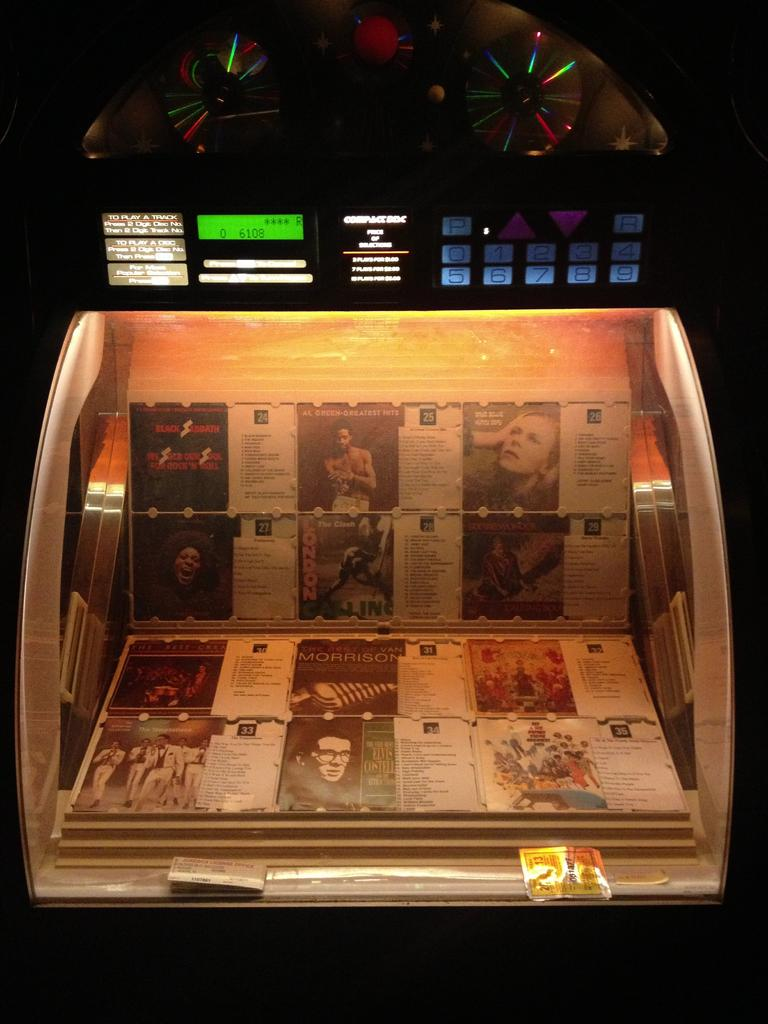What is placed on top of the box in the image? There is an amplifier or electronic machine at the top of the image. What is located on the box in the image? Papers are on the box in the image. How would you describe the lighting at the bottom of the image? The bottom of the image appears to be dark. How many pets are visible in the image? There are no pets present in the image. What type of government is depicted in the image? There is no reference to a government in the image. 